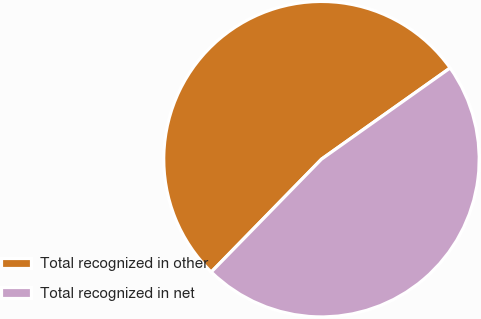<chart> <loc_0><loc_0><loc_500><loc_500><pie_chart><fcel>Total recognized in other<fcel>Total recognized in net<nl><fcel>52.87%<fcel>47.13%<nl></chart> 